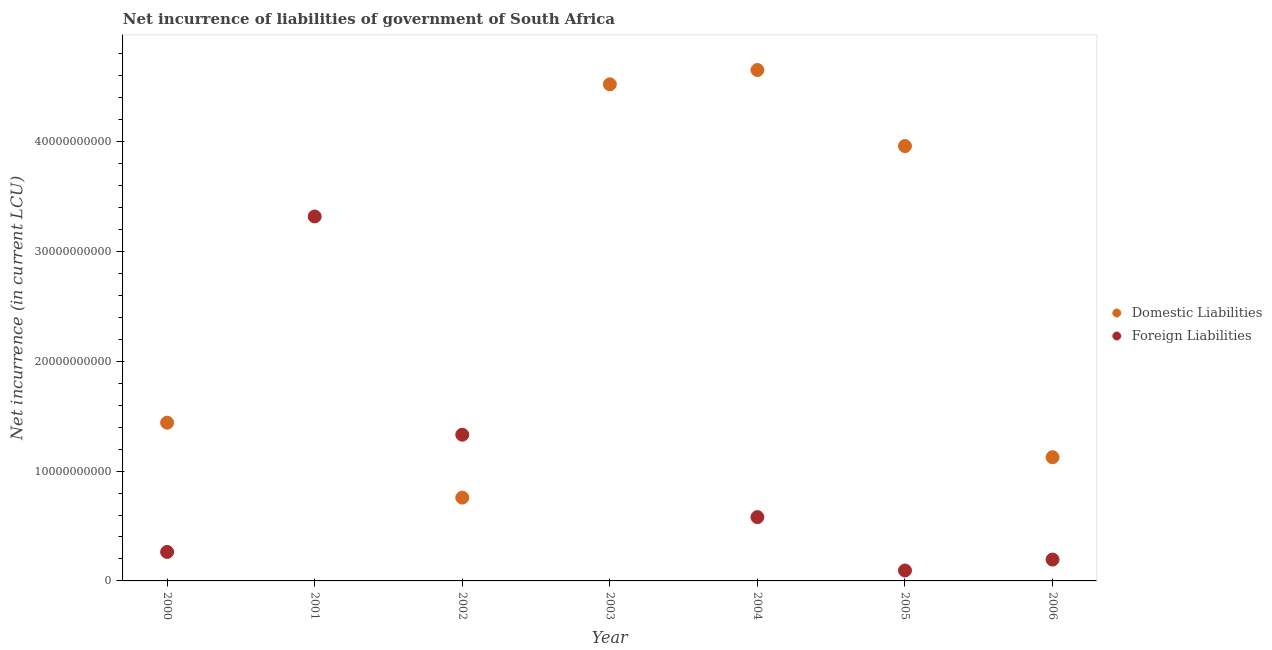How many different coloured dotlines are there?
Your response must be concise. 2. What is the net incurrence of domestic liabilities in 2000?
Offer a terse response. 1.44e+1. Across all years, what is the maximum net incurrence of domestic liabilities?
Ensure brevity in your answer.  4.65e+1. What is the total net incurrence of foreign liabilities in the graph?
Provide a succinct answer. 5.78e+1. What is the difference between the net incurrence of domestic liabilities in 2000 and that in 2005?
Make the answer very short. -2.52e+1. What is the difference between the net incurrence of domestic liabilities in 2000 and the net incurrence of foreign liabilities in 2005?
Ensure brevity in your answer.  1.35e+1. What is the average net incurrence of foreign liabilities per year?
Keep it short and to the point. 8.26e+09. In the year 2004, what is the difference between the net incurrence of domestic liabilities and net incurrence of foreign liabilities?
Offer a very short reply. 4.07e+1. In how many years, is the net incurrence of domestic liabilities greater than 4000000000 LCU?
Provide a succinct answer. 6. What is the ratio of the net incurrence of domestic liabilities in 2002 to that in 2005?
Offer a very short reply. 0.19. Is the net incurrence of foreign liabilities in 2001 less than that in 2002?
Your response must be concise. No. What is the difference between the highest and the second highest net incurrence of foreign liabilities?
Your response must be concise. 1.99e+1. What is the difference between the highest and the lowest net incurrence of domestic liabilities?
Make the answer very short. 4.65e+1. In how many years, is the net incurrence of foreign liabilities greater than the average net incurrence of foreign liabilities taken over all years?
Your answer should be very brief. 2. Is the sum of the net incurrence of domestic liabilities in 2005 and 2006 greater than the maximum net incurrence of foreign liabilities across all years?
Offer a very short reply. Yes. Is the net incurrence of foreign liabilities strictly less than the net incurrence of domestic liabilities over the years?
Provide a short and direct response. No. What is the difference between two consecutive major ticks on the Y-axis?
Offer a very short reply. 1.00e+1. Does the graph contain grids?
Your answer should be compact. No. How many legend labels are there?
Keep it short and to the point. 2. How are the legend labels stacked?
Offer a very short reply. Vertical. What is the title of the graph?
Offer a terse response. Net incurrence of liabilities of government of South Africa. What is the label or title of the X-axis?
Make the answer very short. Year. What is the label or title of the Y-axis?
Give a very brief answer. Net incurrence (in current LCU). What is the Net incurrence (in current LCU) in Domestic Liabilities in 2000?
Your response must be concise. 1.44e+1. What is the Net incurrence (in current LCU) in Foreign Liabilities in 2000?
Your answer should be compact. 2.64e+09. What is the Net incurrence (in current LCU) of Domestic Liabilities in 2001?
Your response must be concise. 0. What is the Net incurrence (in current LCU) in Foreign Liabilities in 2001?
Make the answer very short. 3.32e+1. What is the Net incurrence (in current LCU) in Domestic Liabilities in 2002?
Offer a very short reply. 7.58e+09. What is the Net incurrence (in current LCU) of Foreign Liabilities in 2002?
Provide a succinct answer. 1.33e+1. What is the Net incurrence (in current LCU) in Domestic Liabilities in 2003?
Offer a very short reply. 4.52e+1. What is the Net incurrence (in current LCU) of Domestic Liabilities in 2004?
Your answer should be very brief. 4.65e+1. What is the Net incurrence (in current LCU) in Foreign Liabilities in 2004?
Ensure brevity in your answer.  5.81e+09. What is the Net incurrence (in current LCU) of Domestic Liabilities in 2005?
Provide a short and direct response. 3.96e+1. What is the Net incurrence (in current LCU) of Foreign Liabilities in 2005?
Offer a terse response. 9.50e+08. What is the Net incurrence (in current LCU) of Domestic Liabilities in 2006?
Provide a succinct answer. 1.13e+1. What is the Net incurrence (in current LCU) in Foreign Liabilities in 2006?
Your answer should be compact. 1.94e+09. Across all years, what is the maximum Net incurrence (in current LCU) in Domestic Liabilities?
Ensure brevity in your answer.  4.65e+1. Across all years, what is the maximum Net incurrence (in current LCU) of Foreign Liabilities?
Your answer should be very brief. 3.32e+1. Across all years, what is the minimum Net incurrence (in current LCU) of Domestic Liabilities?
Your answer should be compact. 0. What is the total Net incurrence (in current LCU) in Domestic Liabilities in the graph?
Keep it short and to the point. 1.65e+11. What is the total Net incurrence (in current LCU) in Foreign Liabilities in the graph?
Make the answer very short. 5.78e+1. What is the difference between the Net incurrence (in current LCU) in Foreign Liabilities in 2000 and that in 2001?
Your answer should be very brief. -3.05e+1. What is the difference between the Net incurrence (in current LCU) in Domestic Liabilities in 2000 and that in 2002?
Offer a terse response. 6.82e+09. What is the difference between the Net incurrence (in current LCU) in Foreign Liabilities in 2000 and that in 2002?
Offer a very short reply. -1.07e+1. What is the difference between the Net incurrence (in current LCU) in Domestic Liabilities in 2000 and that in 2003?
Your answer should be compact. -3.08e+1. What is the difference between the Net incurrence (in current LCU) in Domestic Liabilities in 2000 and that in 2004?
Give a very brief answer. -3.21e+1. What is the difference between the Net incurrence (in current LCU) of Foreign Liabilities in 2000 and that in 2004?
Provide a succinct answer. -3.17e+09. What is the difference between the Net incurrence (in current LCU) in Domestic Liabilities in 2000 and that in 2005?
Keep it short and to the point. -2.52e+1. What is the difference between the Net incurrence (in current LCU) in Foreign Liabilities in 2000 and that in 2005?
Your response must be concise. 1.69e+09. What is the difference between the Net incurrence (in current LCU) in Domestic Liabilities in 2000 and that in 2006?
Give a very brief answer. 3.15e+09. What is the difference between the Net incurrence (in current LCU) in Foreign Liabilities in 2000 and that in 2006?
Offer a very short reply. 6.94e+08. What is the difference between the Net incurrence (in current LCU) in Foreign Liabilities in 2001 and that in 2002?
Your answer should be very brief. 1.99e+1. What is the difference between the Net incurrence (in current LCU) in Foreign Liabilities in 2001 and that in 2004?
Keep it short and to the point. 2.74e+1. What is the difference between the Net incurrence (in current LCU) in Foreign Liabilities in 2001 and that in 2005?
Your response must be concise. 3.22e+1. What is the difference between the Net incurrence (in current LCU) of Foreign Liabilities in 2001 and that in 2006?
Offer a terse response. 3.12e+1. What is the difference between the Net incurrence (in current LCU) in Domestic Liabilities in 2002 and that in 2003?
Your response must be concise. -3.76e+1. What is the difference between the Net incurrence (in current LCU) in Domestic Liabilities in 2002 and that in 2004?
Make the answer very short. -3.89e+1. What is the difference between the Net incurrence (in current LCU) in Foreign Liabilities in 2002 and that in 2004?
Make the answer very short. 7.50e+09. What is the difference between the Net incurrence (in current LCU) in Domestic Liabilities in 2002 and that in 2005?
Ensure brevity in your answer.  -3.20e+1. What is the difference between the Net incurrence (in current LCU) in Foreign Liabilities in 2002 and that in 2005?
Your response must be concise. 1.24e+1. What is the difference between the Net incurrence (in current LCU) of Domestic Liabilities in 2002 and that in 2006?
Provide a short and direct response. -3.68e+09. What is the difference between the Net incurrence (in current LCU) in Foreign Liabilities in 2002 and that in 2006?
Provide a short and direct response. 1.14e+1. What is the difference between the Net incurrence (in current LCU) of Domestic Liabilities in 2003 and that in 2004?
Make the answer very short. -1.30e+09. What is the difference between the Net incurrence (in current LCU) in Domestic Liabilities in 2003 and that in 2005?
Your response must be concise. 5.63e+09. What is the difference between the Net incurrence (in current LCU) in Domestic Liabilities in 2003 and that in 2006?
Keep it short and to the point. 3.40e+1. What is the difference between the Net incurrence (in current LCU) in Domestic Liabilities in 2004 and that in 2005?
Your answer should be very brief. 6.92e+09. What is the difference between the Net incurrence (in current LCU) in Foreign Liabilities in 2004 and that in 2005?
Offer a very short reply. 4.86e+09. What is the difference between the Net incurrence (in current LCU) of Domestic Liabilities in 2004 and that in 2006?
Provide a succinct answer. 3.52e+1. What is the difference between the Net incurrence (in current LCU) in Foreign Liabilities in 2004 and that in 2006?
Your answer should be compact. 3.87e+09. What is the difference between the Net incurrence (in current LCU) in Domestic Liabilities in 2005 and that in 2006?
Give a very brief answer. 2.83e+1. What is the difference between the Net incurrence (in current LCU) of Foreign Liabilities in 2005 and that in 2006?
Ensure brevity in your answer.  -9.93e+08. What is the difference between the Net incurrence (in current LCU) in Domestic Liabilities in 2000 and the Net incurrence (in current LCU) in Foreign Liabilities in 2001?
Your response must be concise. -1.88e+1. What is the difference between the Net incurrence (in current LCU) in Domestic Liabilities in 2000 and the Net incurrence (in current LCU) in Foreign Liabilities in 2002?
Offer a very short reply. 1.10e+09. What is the difference between the Net incurrence (in current LCU) of Domestic Liabilities in 2000 and the Net incurrence (in current LCU) of Foreign Liabilities in 2004?
Give a very brief answer. 8.60e+09. What is the difference between the Net incurrence (in current LCU) in Domestic Liabilities in 2000 and the Net incurrence (in current LCU) in Foreign Liabilities in 2005?
Provide a succinct answer. 1.35e+1. What is the difference between the Net incurrence (in current LCU) of Domestic Liabilities in 2000 and the Net incurrence (in current LCU) of Foreign Liabilities in 2006?
Give a very brief answer. 1.25e+1. What is the difference between the Net incurrence (in current LCU) of Domestic Liabilities in 2002 and the Net incurrence (in current LCU) of Foreign Liabilities in 2004?
Your answer should be very brief. 1.78e+09. What is the difference between the Net incurrence (in current LCU) in Domestic Liabilities in 2002 and the Net incurrence (in current LCU) in Foreign Liabilities in 2005?
Your answer should be very brief. 6.63e+09. What is the difference between the Net incurrence (in current LCU) in Domestic Liabilities in 2002 and the Net incurrence (in current LCU) in Foreign Liabilities in 2006?
Keep it short and to the point. 5.64e+09. What is the difference between the Net incurrence (in current LCU) of Domestic Liabilities in 2003 and the Net incurrence (in current LCU) of Foreign Liabilities in 2004?
Ensure brevity in your answer.  3.94e+1. What is the difference between the Net incurrence (in current LCU) in Domestic Liabilities in 2003 and the Net incurrence (in current LCU) in Foreign Liabilities in 2005?
Your response must be concise. 4.43e+1. What is the difference between the Net incurrence (in current LCU) in Domestic Liabilities in 2003 and the Net incurrence (in current LCU) in Foreign Liabilities in 2006?
Provide a succinct answer. 4.33e+1. What is the difference between the Net incurrence (in current LCU) of Domestic Liabilities in 2004 and the Net incurrence (in current LCU) of Foreign Liabilities in 2005?
Keep it short and to the point. 4.56e+1. What is the difference between the Net incurrence (in current LCU) of Domestic Liabilities in 2004 and the Net incurrence (in current LCU) of Foreign Liabilities in 2006?
Give a very brief answer. 4.46e+1. What is the difference between the Net incurrence (in current LCU) in Domestic Liabilities in 2005 and the Net incurrence (in current LCU) in Foreign Liabilities in 2006?
Provide a succinct answer. 3.76e+1. What is the average Net incurrence (in current LCU) in Domestic Liabilities per year?
Ensure brevity in your answer.  2.35e+1. What is the average Net incurrence (in current LCU) of Foreign Liabilities per year?
Provide a succinct answer. 8.26e+09. In the year 2000, what is the difference between the Net incurrence (in current LCU) of Domestic Liabilities and Net incurrence (in current LCU) of Foreign Liabilities?
Provide a short and direct response. 1.18e+1. In the year 2002, what is the difference between the Net incurrence (in current LCU) in Domestic Liabilities and Net incurrence (in current LCU) in Foreign Liabilities?
Ensure brevity in your answer.  -5.72e+09. In the year 2004, what is the difference between the Net incurrence (in current LCU) in Domestic Liabilities and Net incurrence (in current LCU) in Foreign Liabilities?
Give a very brief answer. 4.07e+1. In the year 2005, what is the difference between the Net incurrence (in current LCU) in Domestic Liabilities and Net incurrence (in current LCU) in Foreign Liabilities?
Your response must be concise. 3.86e+1. In the year 2006, what is the difference between the Net incurrence (in current LCU) in Domestic Liabilities and Net incurrence (in current LCU) in Foreign Liabilities?
Offer a very short reply. 9.32e+09. What is the ratio of the Net incurrence (in current LCU) of Foreign Liabilities in 2000 to that in 2001?
Keep it short and to the point. 0.08. What is the ratio of the Net incurrence (in current LCU) of Domestic Liabilities in 2000 to that in 2002?
Offer a very short reply. 1.9. What is the ratio of the Net incurrence (in current LCU) of Foreign Liabilities in 2000 to that in 2002?
Offer a terse response. 0.2. What is the ratio of the Net incurrence (in current LCU) in Domestic Liabilities in 2000 to that in 2003?
Your answer should be very brief. 0.32. What is the ratio of the Net incurrence (in current LCU) of Domestic Liabilities in 2000 to that in 2004?
Provide a succinct answer. 0.31. What is the ratio of the Net incurrence (in current LCU) in Foreign Liabilities in 2000 to that in 2004?
Give a very brief answer. 0.45. What is the ratio of the Net incurrence (in current LCU) of Domestic Liabilities in 2000 to that in 2005?
Provide a succinct answer. 0.36. What is the ratio of the Net incurrence (in current LCU) in Foreign Liabilities in 2000 to that in 2005?
Keep it short and to the point. 2.78. What is the ratio of the Net incurrence (in current LCU) in Domestic Liabilities in 2000 to that in 2006?
Your response must be concise. 1.28. What is the ratio of the Net incurrence (in current LCU) of Foreign Liabilities in 2000 to that in 2006?
Your answer should be compact. 1.36. What is the ratio of the Net incurrence (in current LCU) of Foreign Liabilities in 2001 to that in 2002?
Make the answer very short. 2.49. What is the ratio of the Net incurrence (in current LCU) in Foreign Liabilities in 2001 to that in 2004?
Your answer should be compact. 5.71. What is the ratio of the Net incurrence (in current LCU) of Foreign Liabilities in 2001 to that in 2005?
Your response must be concise. 34.92. What is the ratio of the Net incurrence (in current LCU) in Foreign Liabilities in 2001 to that in 2006?
Your answer should be very brief. 17.08. What is the ratio of the Net incurrence (in current LCU) of Domestic Liabilities in 2002 to that in 2003?
Offer a very short reply. 0.17. What is the ratio of the Net incurrence (in current LCU) in Domestic Liabilities in 2002 to that in 2004?
Your answer should be very brief. 0.16. What is the ratio of the Net incurrence (in current LCU) of Foreign Liabilities in 2002 to that in 2004?
Keep it short and to the point. 2.29. What is the ratio of the Net incurrence (in current LCU) of Domestic Liabilities in 2002 to that in 2005?
Keep it short and to the point. 0.19. What is the ratio of the Net incurrence (in current LCU) in Foreign Liabilities in 2002 to that in 2005?
Provide a succinct answer. 14.01. What is the ratio of the Net incurrence (in current LCU) of Domestic Liabilities in 2002 to that in 2006?
Make the answer very short. 0.67. What is the ratio of the Net incurrence (in current LCU) in Foreign Liabilities in 2002 to that in 2006?
Offer a terse response. 6.85. What is the ratio of the Net incurrence (in current LCU) in Domestic Liabilities in 2003 to that in 2004?
Ensure brevity in your answer.  0.97. What is the ratio of the Net incurrence (in current LCU) of Domestic Liabilities in 2003 to that in 2005?
Offer a terse response. 1.14. What is the ratio of the Net incurrence (in current LCU) in Domestic Liabilities in 2003 to that in 2006?
Your answer should be very brief. 4.01. What is the ratio of the Net incurrence (in current LCU) in Domestic Liabilities in 2004 to that in 2005?
Offer a very short reply. 1.17. What is the ratio of the Net incurrence (in current LCU) of Foreign Liabilities in 2004 to that in 2005?
Provide a short and direct response. 6.11. What is the ratio of the Net incurrence (in current LCU) of Domestic Liabilities in 2004 to that in 2006?
Give a very brief answer. 4.13. What is the ratio of the Net incurrence (in current LCU) of Foreign Liabilities in 2004 to that in 2006?
Give a very brief answer. 2.99. What is the ratio of the Net incurrence (in current LCU) of Domestic Liabilities in 2005 to that in 2006?
Keep it short and to the point. 3.52. What is the ratio of the Net incurrence (in current LCU) in Foreign Liabilities in 2005 to that in 2006?
Your answer should be very brief. 0.49. What is the difference between the highest and the second highest Net incurrence (in current LCU) of Domestic Liabilities?
Your answer should be compact. 1.30e+09. What is the difference between the highest and the second highest Net incurrence (in current LCU) of Foreign Liabilities?
Provide a succinct answer. 1.99e+1. What is the difference between the highest and the lowest Net incurrence (in current LCU) of Domestic Liabilities?
Your answer should be very brief. 4.65e+1. What is the difference between the highest and the lowest Net incurrence (in current LCU) in Foreign Liabilities?
Your response must be concise. 3.32e+1. 